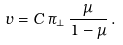Convert formula to latex. <formula><loc_0><loc_0><loc_500><loc_500>v = C \, \pi _ { \perp } \, \frac { \mu } { 1 - \mu } \, .</formula> 